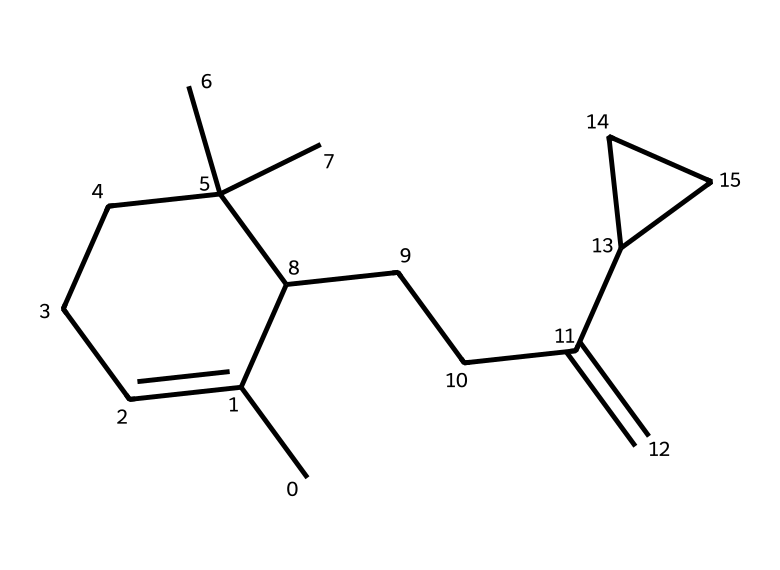What is the molecular formula of caryophyllene? To find the molecular formula, count the number of carbon (C) and hydrogen (H) atoms in the SMILES representation. The structure contains 15 carbon atoms and 24 hydrogen atoms. Therefore, the molecular formula is C15H24.
Answer: C15H24 How many rings are present in the structure of caryophyllene? Observing the SMILES notation, we can identify two instances of 'C' followed by numbers which indicate ring closures. Hence, there are two rings within the chemical structure.
Answer: 2 What type of polymerization reaction does caryophyllene undergo? Caryophyllene can undergo addition reactions typical of terpenes, allowing it to participate in processes like polymerization, common for its double bonds. The presence of a cyclic structure also aids its reactivity in various chemical reactions.
Answer: addition Which functional groups are present in caryophyllene? In examining the structure, caryophyllene predominantly exhibits alkene functional groups due to the presence of a double bond (represented in the structure statement, specifically "C=C").
Answer: alkene What is the significance of caryophyllene in traditional medicine? Caryophyllene has been historically used for its anti-inflammatory properties and is found in various medicinal plants that were cultivated in historical regions, including Troy. This highlights its relevance in traditional remedies.
Answer: anti-inflammatory What is the overall shape of the caryophyllene molecule? The caryophyllene molecule has a complex, three-dimensional shape, indicated by multiple branching points and rings within its structure, resulting in a non-linear, bulky configuration commonly observed in terpenes.
Answer: bulky 